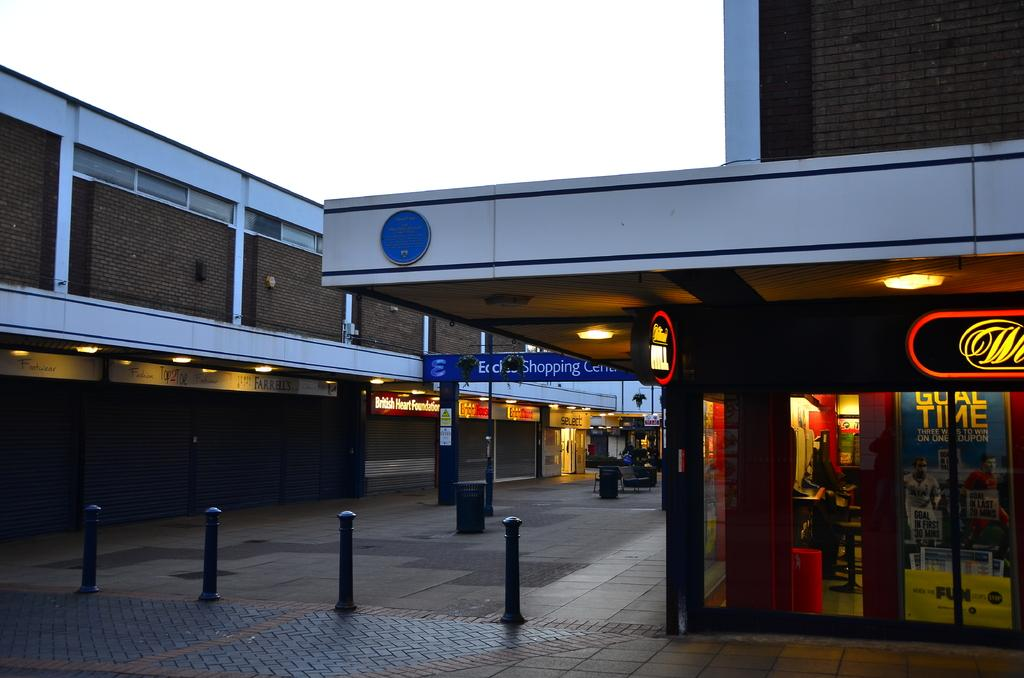<image>
Create a compact narrative representing the image presented. A shopping precinct in the evening and the British Heart Foundation is closed. 